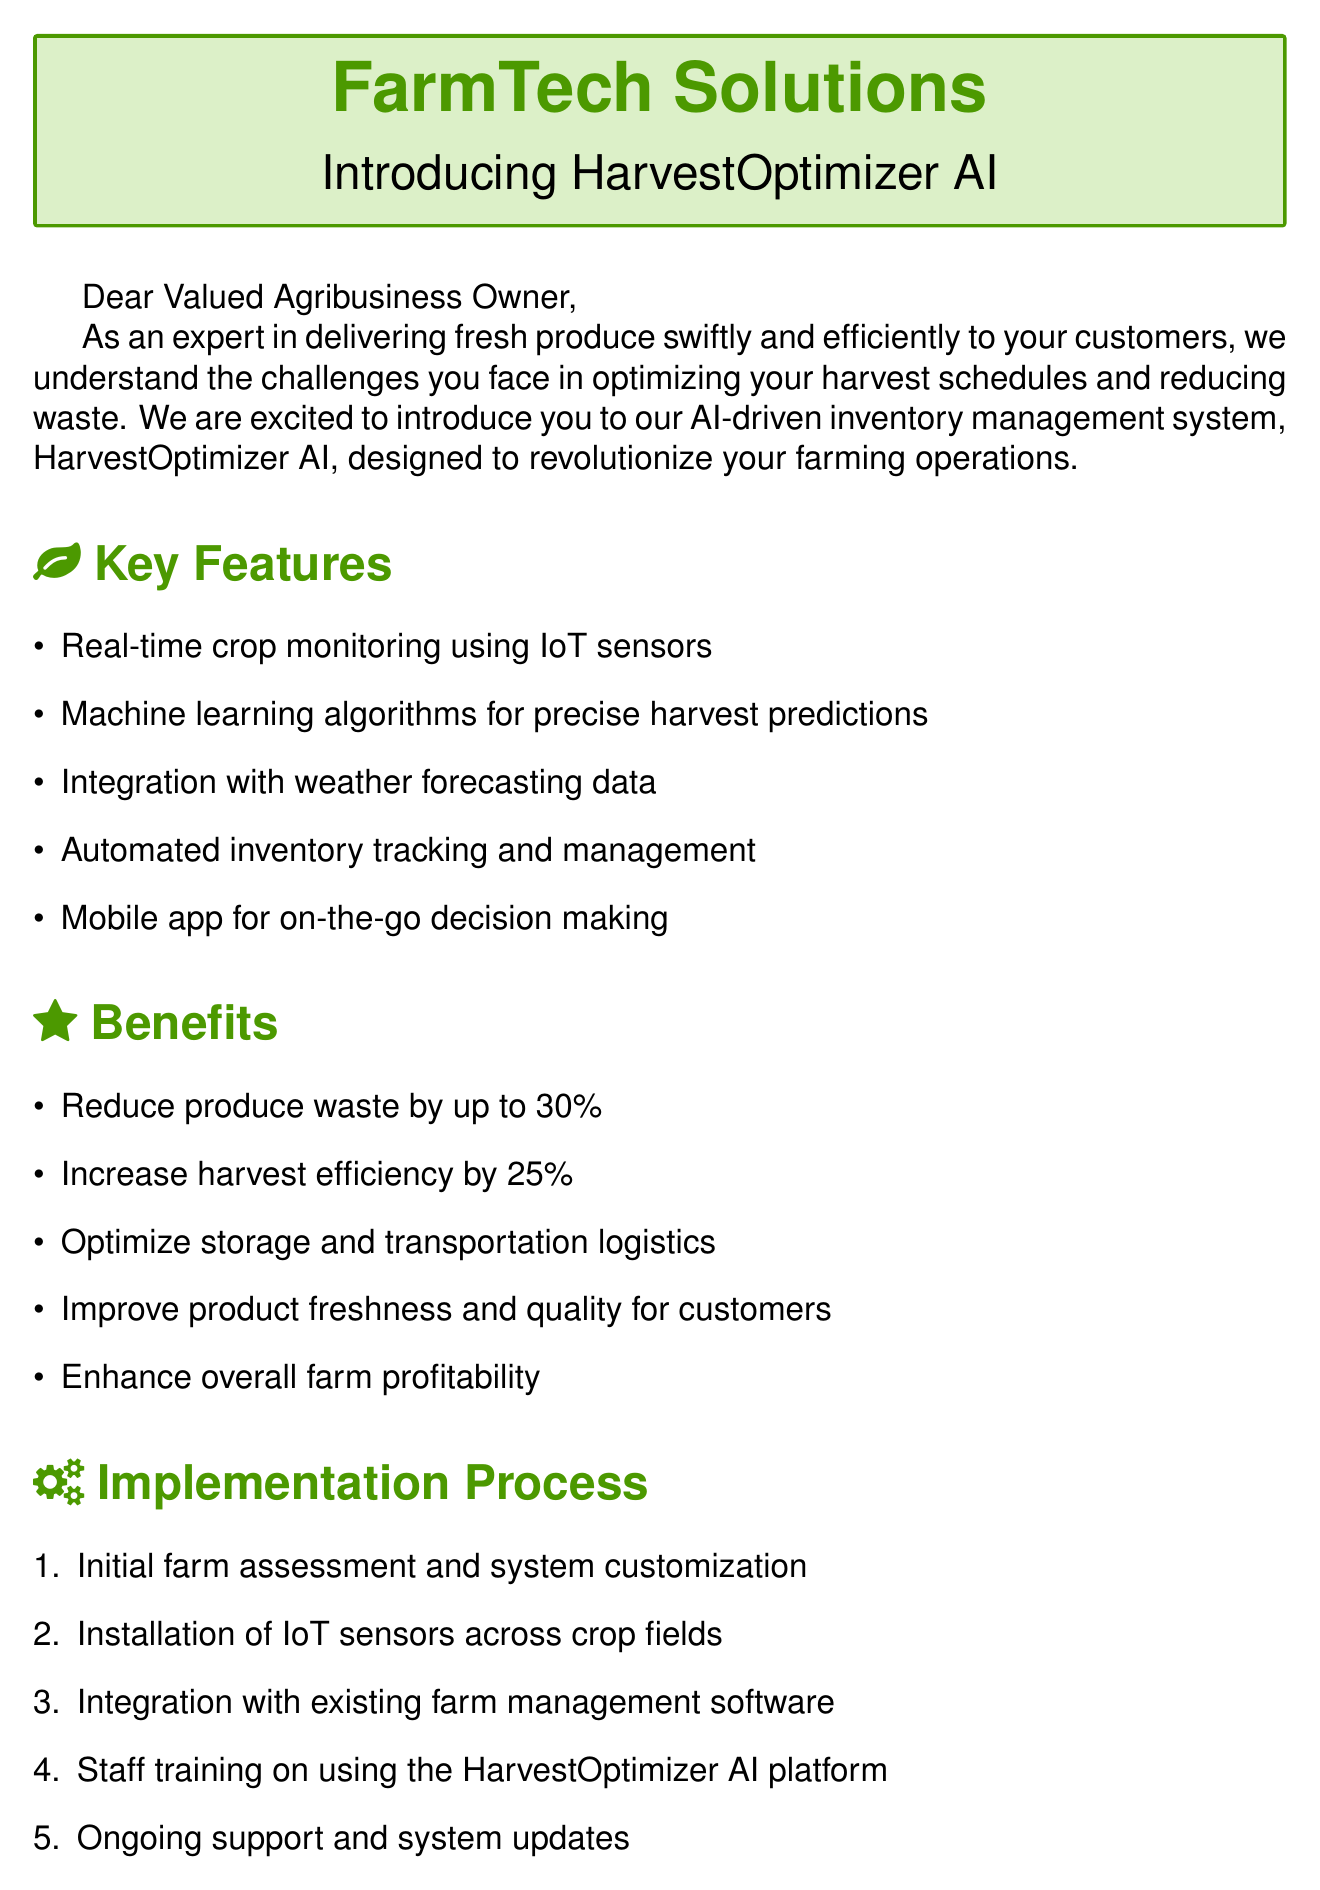what is the name of the startup? The startup offering the inventory management system is FarmTech Solutions.
Answer: FarmTech Solutions what is the product being offered? The AI-driven inventory management system is referred to as HarvestOptimizer AI.
Answer: HarvestOptimizer AI how much does the premium plan cost? The premium plan's pricing is specified in the document as $12,000 per year.
Answer: $12,000 per year what is one of the key features of HarvestOptimizer AI? The document lists several features; one of them is real-time crop monitoring using IoT sensors.
Answer: Real-time crop monitoring using IoT sensors what percentage can produce waste be reduced by? The proposal indicates that produce waste can be reduced by up to 30%.
Answer: 30% what was the revenue increase reported by Green Valley Orchards? The results show that Green Valley Orchards increased revenue by $150,000 due to improved harvest timing.
Answer: $150,000 how much can harvest efficiency increase according to the benefits? The document states that harvest efficiency can increase by 25%.
Answer: 25% what step comes first in the implementation process? The first step in the implementation process is the initial farm assessment and system customization.
Answer: Initial farm assessment and system customization who provided a testimonial for HarvestOptimizer AI? The testimonial was given by John Thompson, Owner of Thompson Family Farms.
Answer: John Thompson 